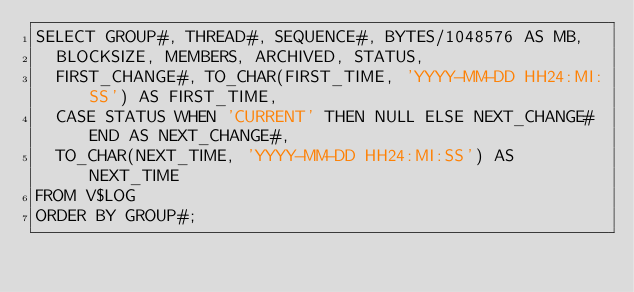Convert code to text. <code><loc_0><loc_0><loc_500><loc_500><_SQL_>SELECT GROUP#, THREAD#, SEQUENCE#, BYTES/1048576 AS MB, 
  BLOCKSIZE, MEMBERS, ARCHIVED, STATUS, 
  FIRST_CHANGE#, TO_CHAR(FIRST_TIME, 'YYYY-MM-DD HH24:MI:SS') AS FIRST_TIME, 
  CASE STATUS WHEN 'CURRENT' THEN NULL ELSE NEXT_CHANGE# END AS NEXT_CHANGE#, 
  TO_CHAR(NEXT_TIME, 'YYYY-MM-DD HH24:MI:SS') AS NEXT_TIME
FROM V$LOG
ORDER BY GROUP#;
</code> 